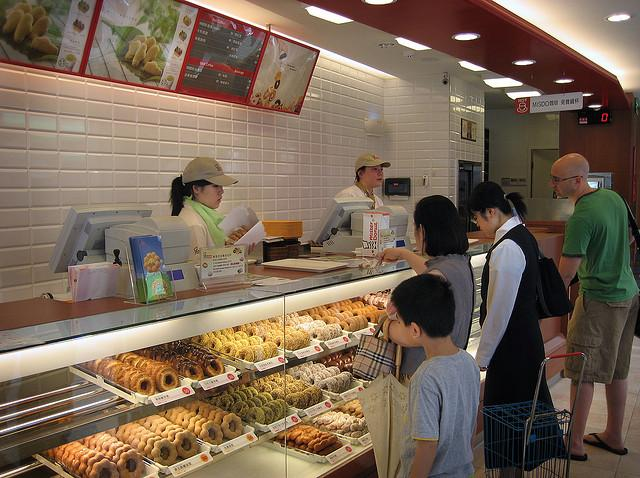In which liquid were most of the shown treats boiled? oil 